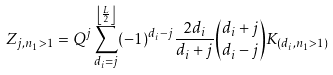Convert formula to latex. <formula><loc_0><loc_0><loc_500><loc_500>Z _ { j , n _ { 1 } > 1 } = Q ^ { j } \sum _ { d _ { i } = j } ^ { \left \lfloor \frac { L } { 2 } \right \rfloor } ( - 1 ) ^ { d _ { i } - j } \frac { 2 d _ { i } } { d _ { i } + j } { d _ { i } + j \choose d _ { i } - j } K _ { ( d _ { i } , n _ { 1 } > 1 ) }</formula> 